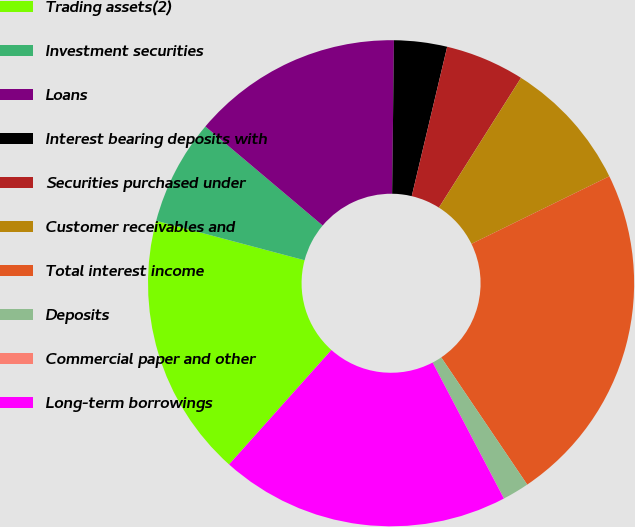<chart> <loc_0><loc_0><loc_500><loc_500><pie_chart><fcel>Trading assets(2)<fcel>Investment securities<fcel>Loans<fcel>Interest bearing deposits with<fcel>Securities purchased under<fcel>Customer receivables and<fcel>Total interest income<fcel>Deposits<fcel>Commercial paper and other<fcel>Long-term borrowings<nl><fcel>17.53%<fcel>7.02%<fcel>14.03%<fcel>3.52%<fcel>5.27%<fcel>8.77%<fcel>22.79%<fcel>1.77%<fcel>0.01%<fcel>19.29%<nl></chart> 